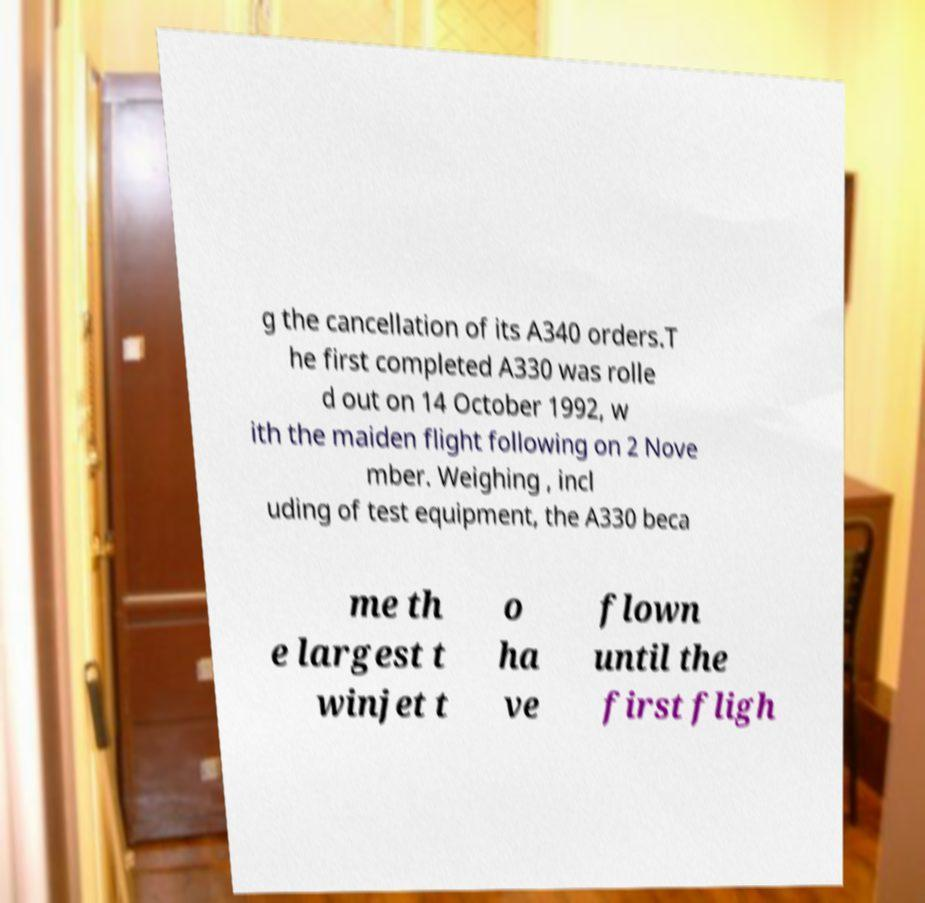For documentation purposes, I need the text within this image transcribed. Could you provide that? g the cancellation of its A340 orders.T he first completed A330 was rolle d out on 14 October 1992, w ith the maiden flight following on 2 Nove mber. Weighing , incl uding of test equipment, the A330 beca me th e largest t winjet t o ha ve flown until the first fligh 